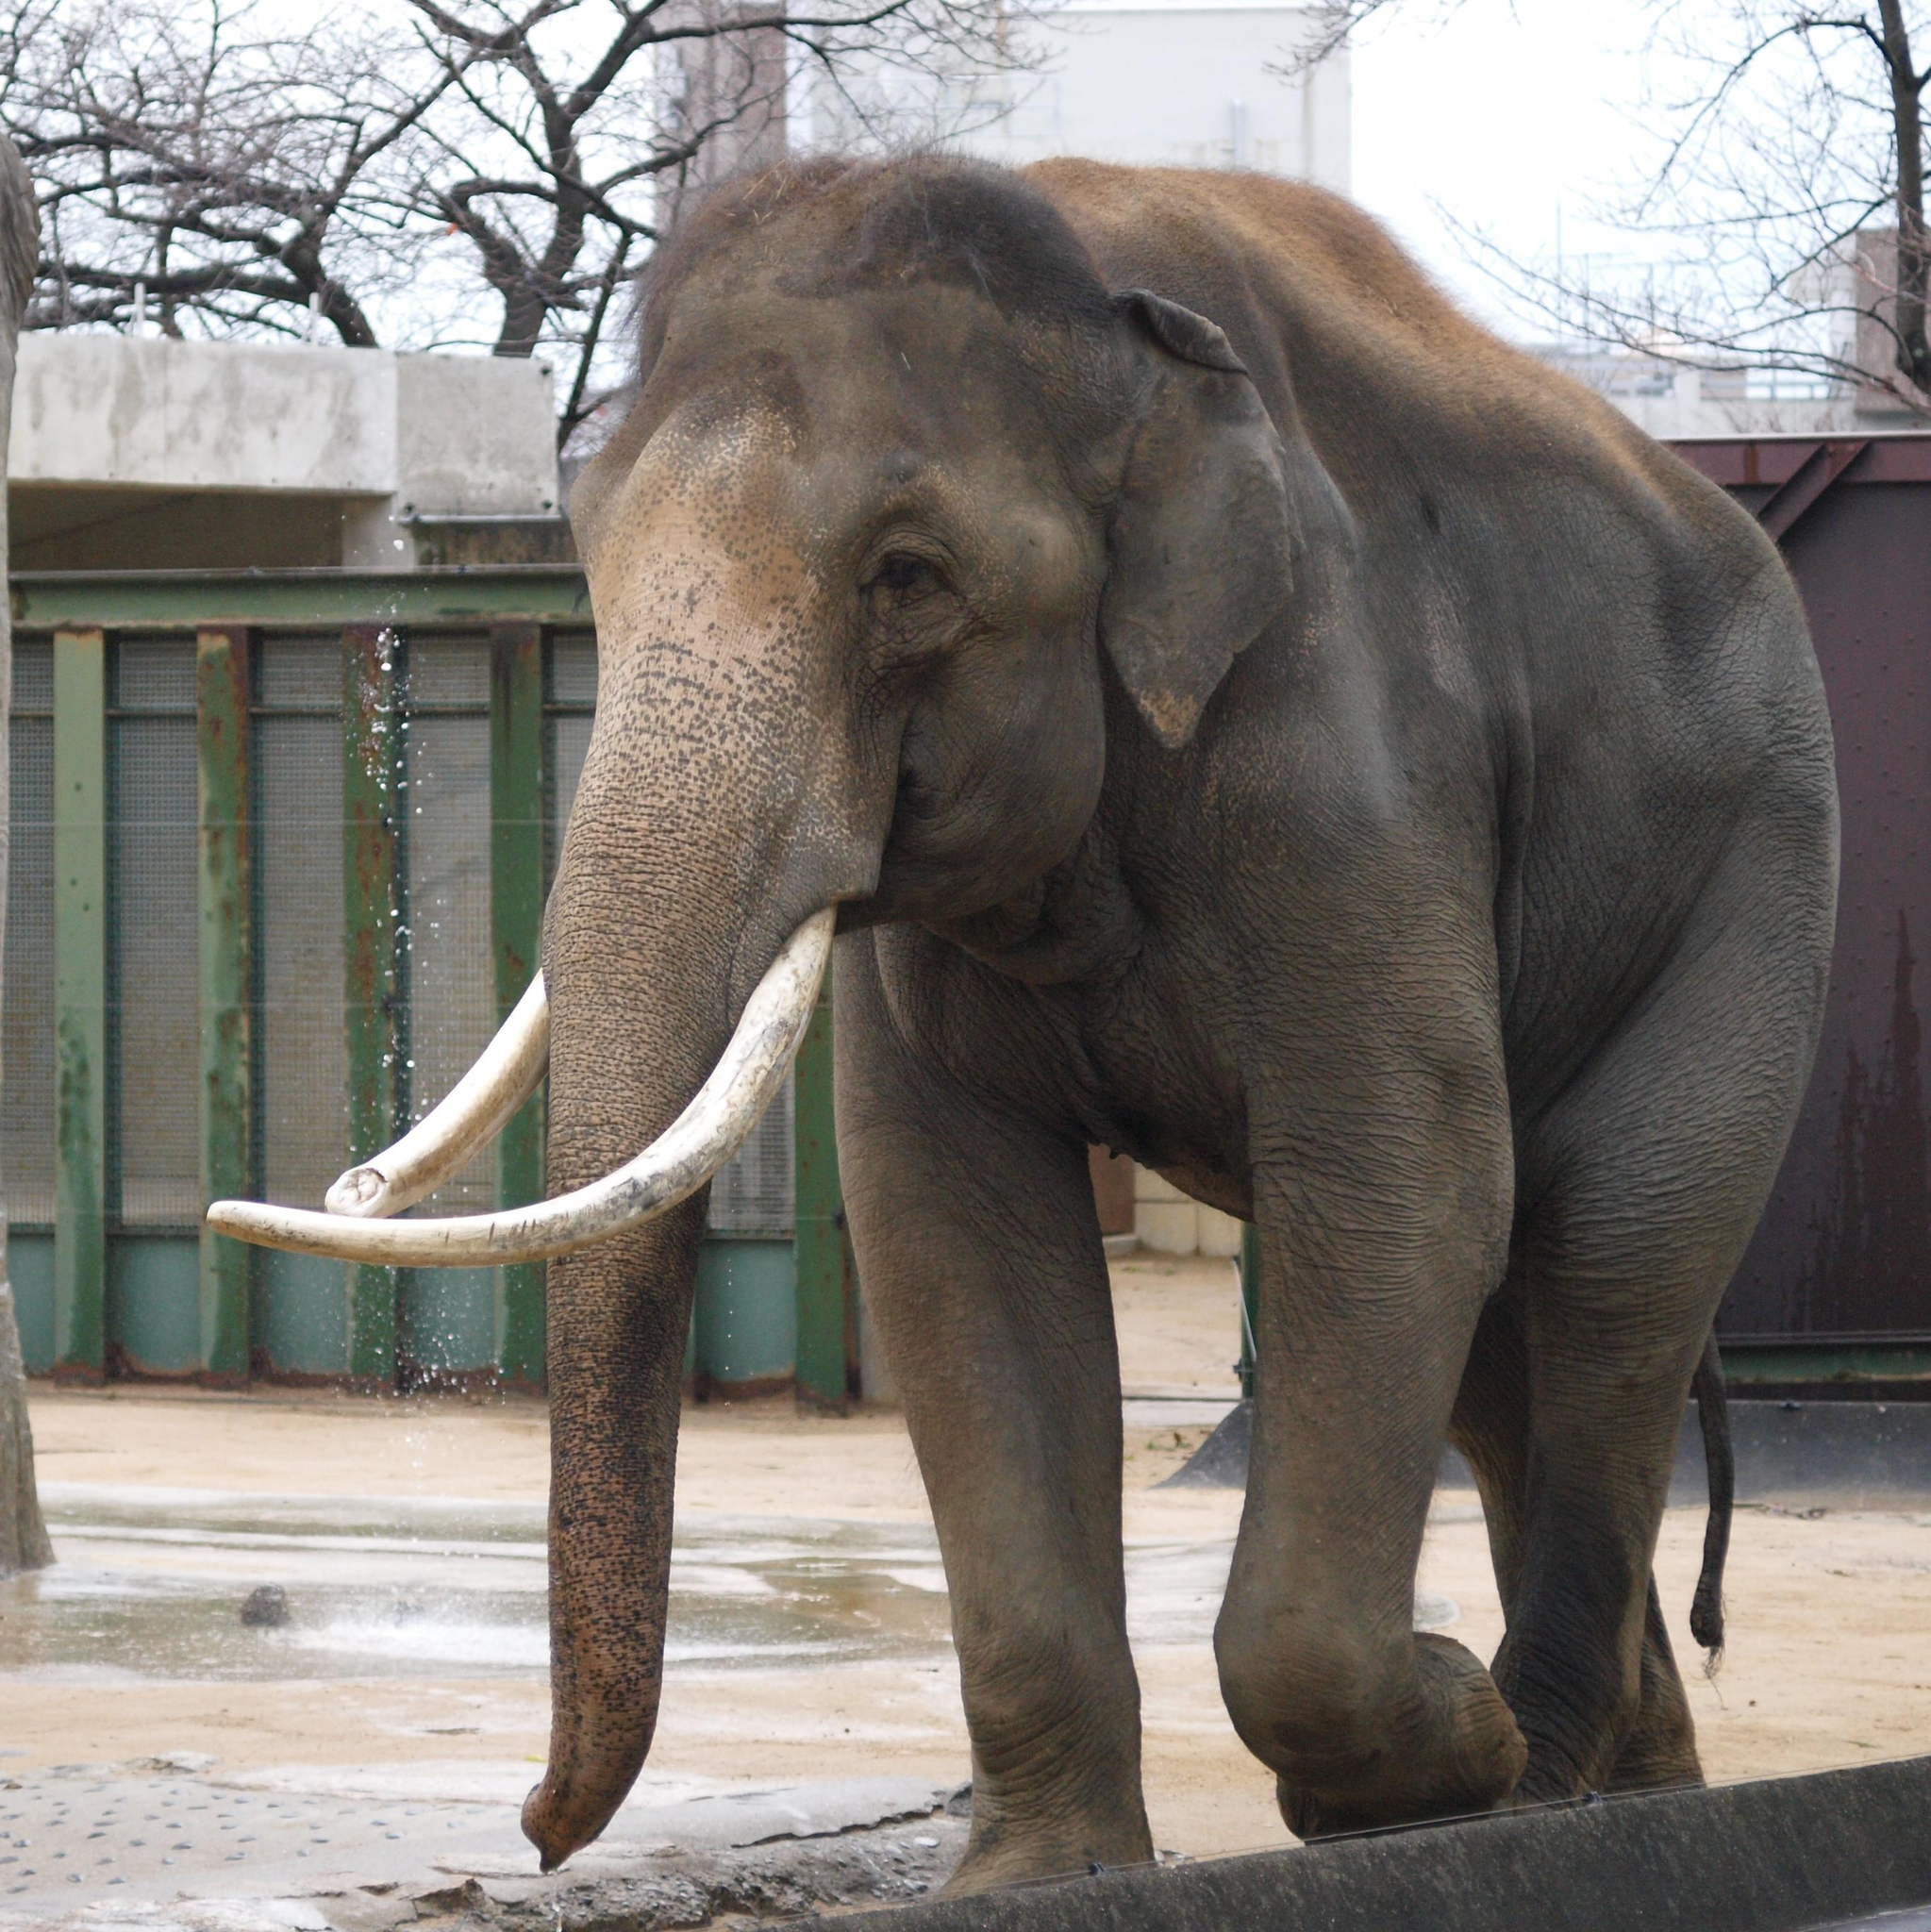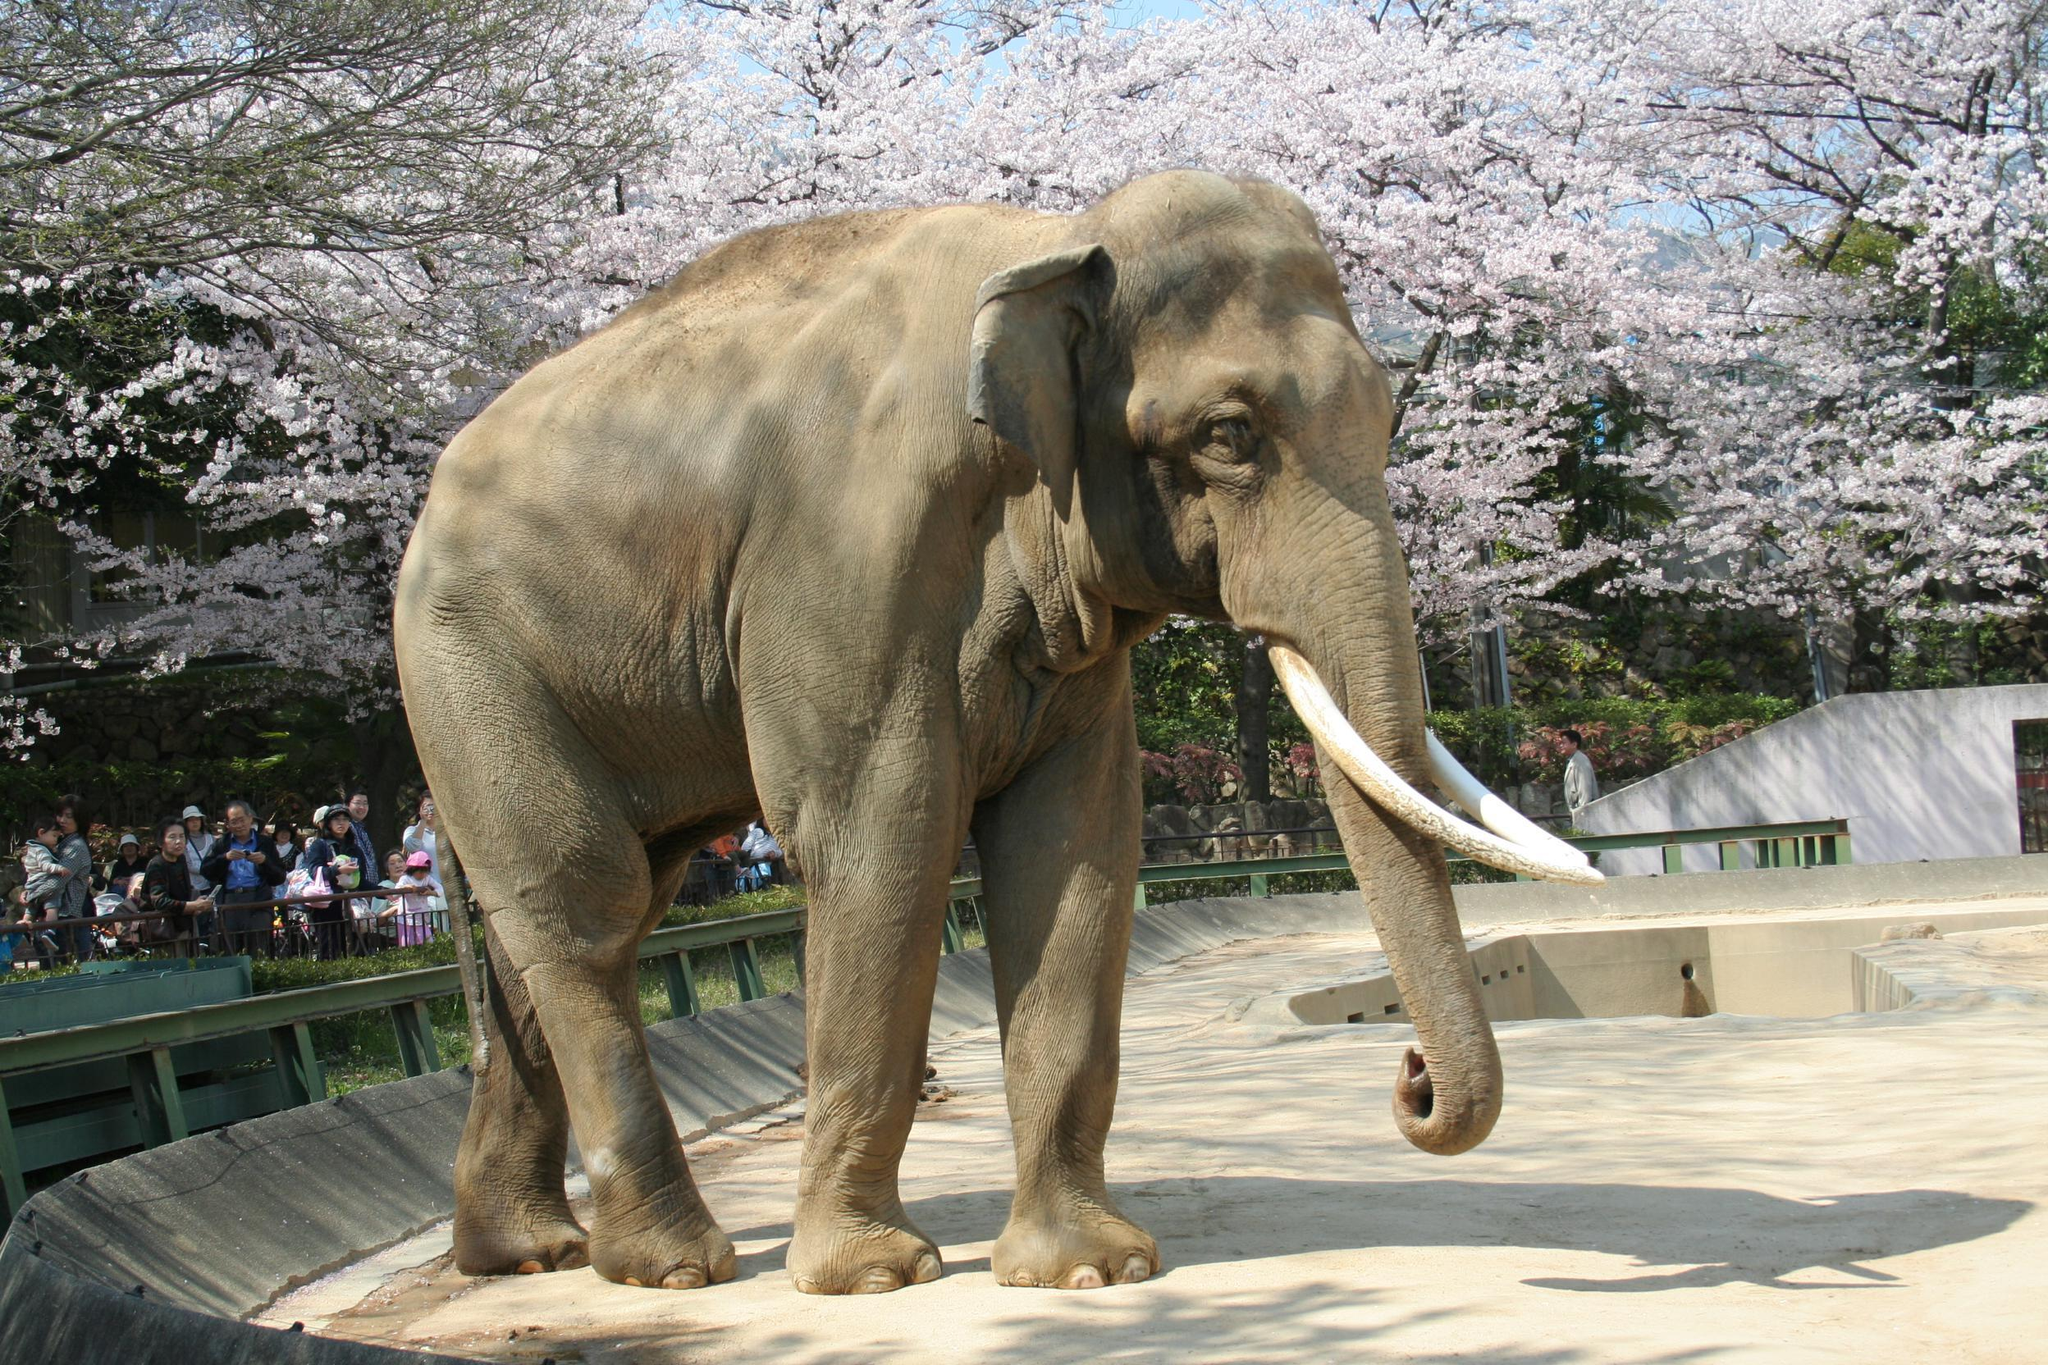The first image is the image on the left, the second image is the image on the right. Examine the images to the left and right. Is the description "An image shows one elephant standing on a surface surrounded by a curved raised edge." accurate? Answer yes or no. Yes. The first image is the image on the left, the second image is the image on the right. Assess this claim about the two images: "The elephant in the right image is facing towards the right.". Correct or not? Answer yes or no. Yes. 